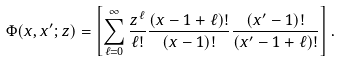Convert formula to latex. <formula><loc_0><loc_0><loc_500><loc_500>\Phi ( x , x ^ { \prime } ; z ) = \left [ \sum _ { \ell = 0 } ^ { \infty } \frac { z ^ { \ell } } { \ell ! } \frac { ( x - 1 + \ell ) ! } { ( x - 1 ) ! } \frac { ( x ^ { \prime } - 1 ) ! } { ( x ^ { \prime } - 1 + \ell ) ! } \right ] .</formula> 